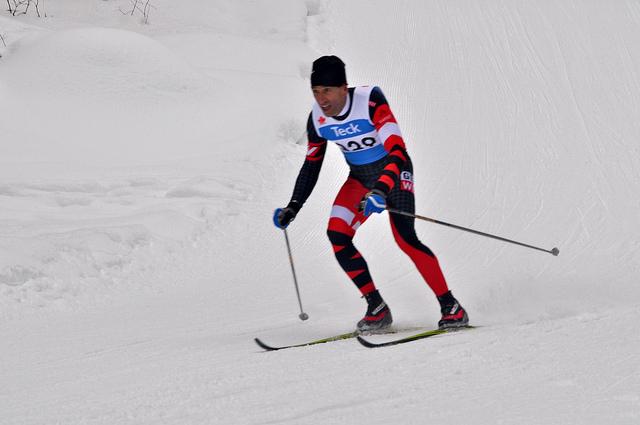What is the number on the skier?
Be succinct. 120. What color is the man's uniform?
Write a very short answer. Red, white, and black. What number is on the blue skier?
Concise answer only. 138. Is the person in the air?
Answer briefly. No. Is the man wearing tight clothes?
Give a very brief answer. Yes. Is the man skiing or snowboarding?
Quick response, please. Skiing. Is this person wearing protective gear?
Answer briefly. No. Is the man wearing goggles?
Be succinct. No. Is this a male?
Answer briefly. Yes. What is the writing on the bottom?
Be succinct. Teck. Is the man's head warm?
Quick response, please. Yes. Is this a male or female?
Give a very brief answer. Male. Is this man turning?
Write a very short answer. Yes. Is this a professional skier?
Short answer required. Yes. What is the man's entry number?
Short answer required. 220. What does his vest say?
Quick response, please. Teck. What kind of jacket is the person wearing?
Short answer required. Ski. Is this person wearing a hat?
Give a very brief answer. Yes. Is the man wearing glasses?
Quick response, please. No. What number contestant is he?
Be succinct. 328. What is the number on the right person's shirt?
Give a very brief answer. 128. What is written on the man's shirt?
Write a very short answer. Teck. What is the skier's number?
Give a very brief answer. 120. 